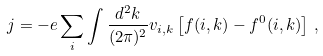Convert formula to latex. <formula><loc_0><loc_0><loc_500><loc_500>j = - e \sum _ { i } \int \frac { d ^ { 2 } k } { ( 2 \pi ) ^ { 2 } } v _ { i , k } \left [ f ( i , k ) - f ^ { 0 } ( i , k ) \right ] \, ,</formula> 